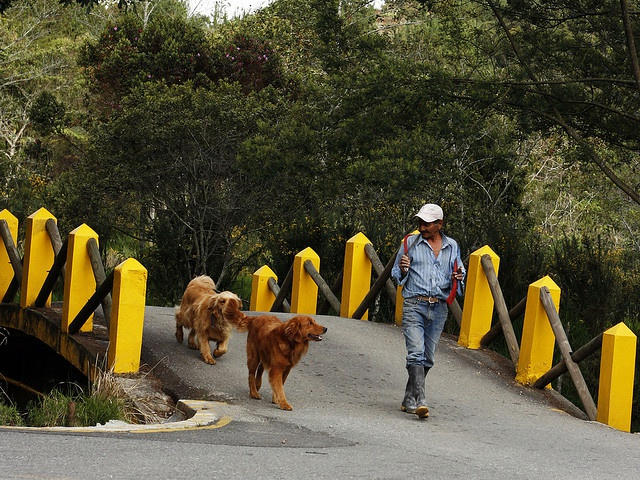Describe the objects in this image and their specific colors. I can see people in black, gray, and darkgray tones, dog in black, maroon, and brown tones, dog in black, maroon, and brown tones, and backpack in black, brown, maroon, and purple tones in this image. 